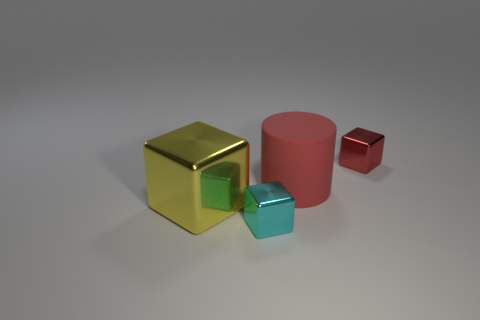What is the tiny thing on the right side of the tiny metal object that is in front of the small object that is right of the rubber object made of?
Your answer should be very brief. Metal. What number of other things are the same color as the large rubber cylinder?
Provide a short and direct response. 1. What number of brown things are either big shiny blocks or small metallic cubes?
Give a very brief answer. 0. What material is the small block that is to the right of the rubber object?
Give a very brief answer. Metal. Is the block that is on the right side of the big cylinder made of the same material as the large cylinder?
Keep it short and to the point. No. The small cyan object has what shape?
Offer a very short reply. Cube. What number of shiny cubes are to the right of the red rubber thing that is behind the tiny metal thing that is on the left side of the small red object?
Your response must be concise. 1. What number of other things are there of the same material as the big red thing
Provide a succinct answer. 0. There is a red cylinder that is the same size as the yellow object; what is its material?
Provide a short and direct response. Rubber. Does the metal object behind the big yellow object have the same color as the big object that is on the right side of the cyan metallic thing?
Your answer should be very brief. Yes. 